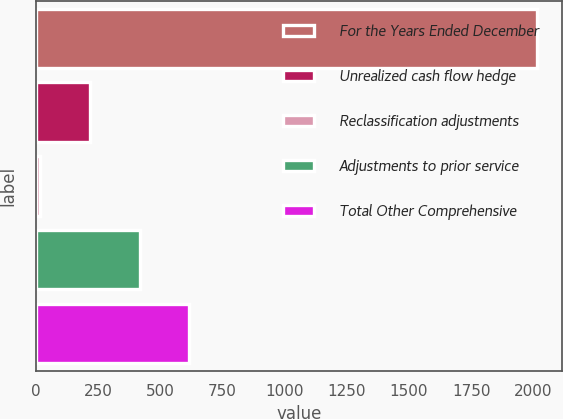Convert chart to OTSL. <chart><loc_0><loc_0><loc_500><loc_500><bar_chart><fcel>For the Years Ended December<fcel>Unrealized cash flow hedge<fcel>Reclassification adjustments<fcel>Adjustments to prior service<fcel>Total Other Comprehensive<nl><fcel>2014<fcel>218.41<fcel>18.9<fcel>417.92<fcel>617.43<nl></chart> 